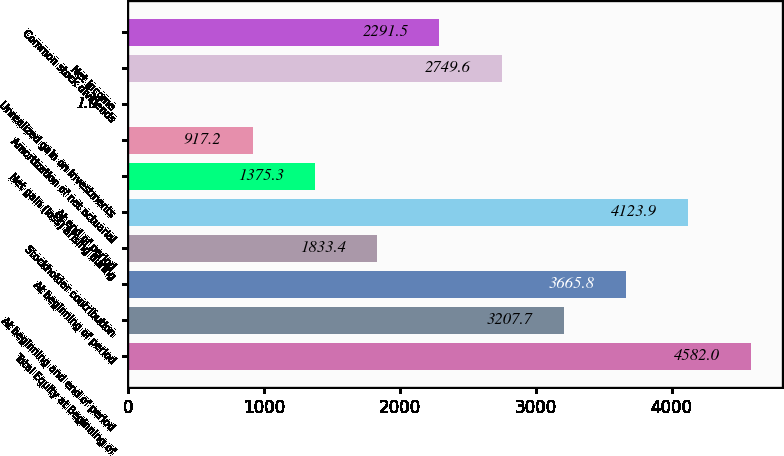Convert chart to OTSL. <chart><loc_0><loc_0><loc_500><loc_500><bar_chart><fcel>Total Equity at Beginning of<fcel>At beginning and end of period<fcel>At beginning of period<fcel>Stockholder contribution<fcel>At end of period<fcel>Net gain (loss) arising during<fcel>Amortization of net actuarial<fcel>Unrealized gain on investments<fcel>Net income<fcel>Common stock dividends<nl><fcel>4582<fcel>3207.7<fcel>3665.8<fcel>1833.4<fcel>4123.9<fcel>1375.3<fcel>917.2<fcel>1<fcel>2749.6<fcel>2291.5<nl></chart> 